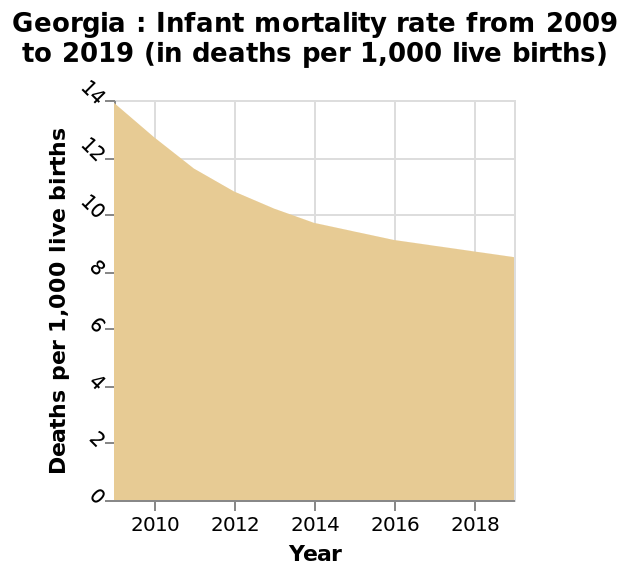<image>
What does the area graph represent in Georgia's infant mortality rate? The area graph represents the trend of infant mortality rate from 2009 to 2019. What is the trend in deaths in Georgia over the past 10 years?  The trend in deaths in Georgia has reduced over the 10 years of the study. Has there been any change in the mortality rate in Georgia over the past decade?  Yes, the mortality rate in Georgia has reduced during the 10 years of the study. Can the study results be used to conclude a decrease in deaths in Georgia? Yes, the study results indicate a reduction in deaths in Georgia over the 10 years. 